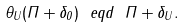Convert formula to latex. <formula><loc_0><loc_0><loc_500><loc_500>\theta _ { U } ( \Pi + \delta _ { 0 } ) \ e q d \ \Pi + \delta _ { U } .</formula> 